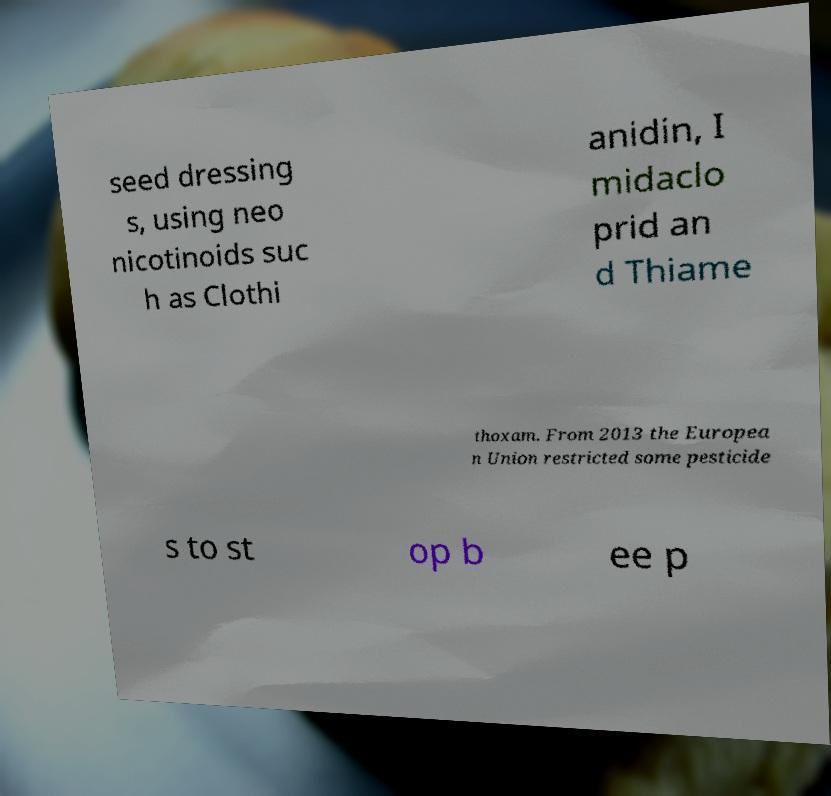Could you extract and type out the text from this image? seed dressing s, using neo nicotinoids suc h as Clothi anidin, I midaclo prid an d Thiame thoxam. From 2013 the Europea n Union restricted some pesticide s to st op b ee p 